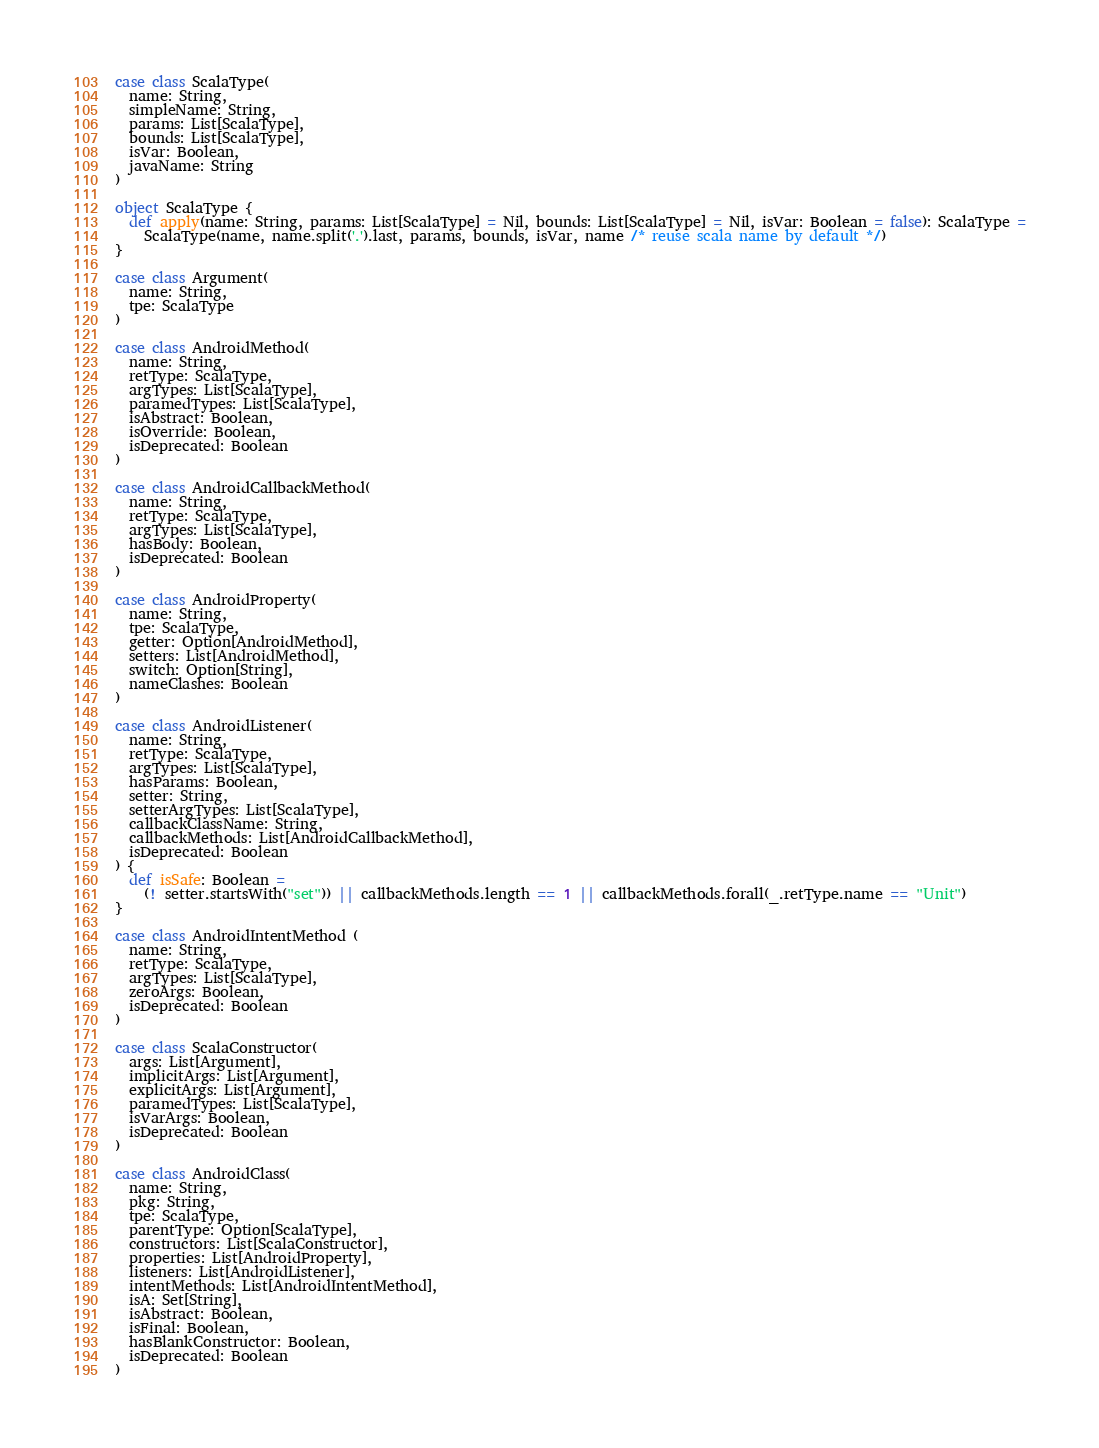<code> <loc_0><loc_0><loc_500><loc_500><_Scala_>
case class ScalaType(
  name: String,
  simpleName: String,
  params: List[ScalaType],
  bounds: List[ScalaType],
  isVar: Boolean,
  javaName: String
)

object ScalaType {
  def apply(name: String, params: List[ScalaType] = Nil, bounds: List[ScalaType] = Nil, isVar: Boolean = false): ScalaType =
    ScalaType(name, name.split('.').last, params, bounds, isVar, name /* reuse scala name by default */)
}

case class Argument(
  name: String,
  tpe: ScalaType
)

case class AndroidMethod(
  name: String,
  retType: ScalaType,
  argTypes: List[ScalaType],
  paramedTypes: List[ScalaType],
  isAbstract: Boolean,
  isOverride: Boolean,
  isDeprecated: Boolean
)

case class AndroidCallbackMethod(
  name: String,
  retType: ScalaType,
  argTypes: List[ScalaType],
  hasBody: Boolean,
  isDeprecated: Boolean
)

case class AndroidProperty(
  name: String,
  tpe: ScalaType,
  getter: Option[AndroidMethod],
  setters: List[AndroidMethod],
  switch: Option[String],
  nameClashes: Boolean
)

case class AndroidListener(
  name: String,
  retType: ScalaType,
  argTypes: List[ScalaType],
  hasParams: Boolean,
  setter: String,
  setterArgTypes: List[ScalaType],
  callbackClassName: String,
  callbackMethods: List[AndroidCallbackMethod],
  isDeprecated: Boolean
) {
  def isSafe: Boolean =
    (! setter.startsWith("set")) || callbackMethods.length == 1 || callbackMethods.forall(_.retType.name == "Unit")
}

case class AndroidIntentMethod (
  name: String,
  retType: ScalaType,
  argTypes: List[ScalaType],
  zeroArgs: Boolean,
  isDeprecated: Boolean
)

case class ScalaConstructor(
  args: List[Argument],
  implicitArgs: List[Argument],
  explicitArgs: List[Argument],
  paramedTypes: List[ScalaType],
  isVarArgs: Boolean,
  isDeprecated: Boolean
)

case class AndroidClass(
  name: String,
  pkg: String,
  tpe: ScalaType,
  parentType: Option[ScalaType],
  constructors: List[ScalaConstructor],
  properties: List[AndroidProperty],
  listeners: List[AndroidListener],
  intentMethods: List[AndroidIntentMethod],
  isA: Set[String],
  isAbstract: Boolean,
  isFinal: Boolean,
  hasBlankConstructor: Boolean,
  isDeprecated: Boolean
)

</code> 